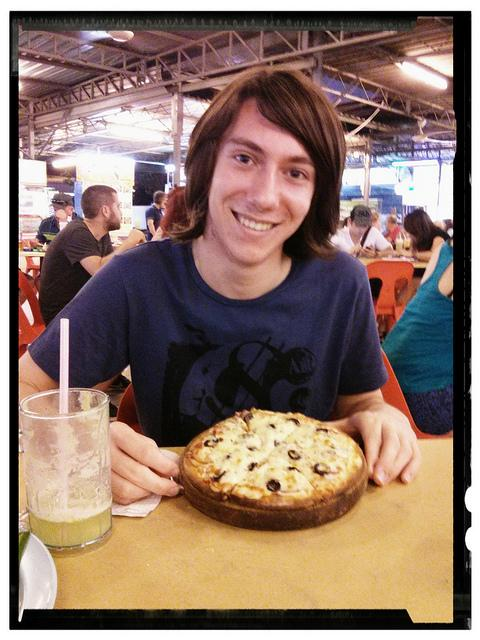What type of crust is this called?

Choices:
A) cheese
B) grilled
C) thin
D) thick thick 